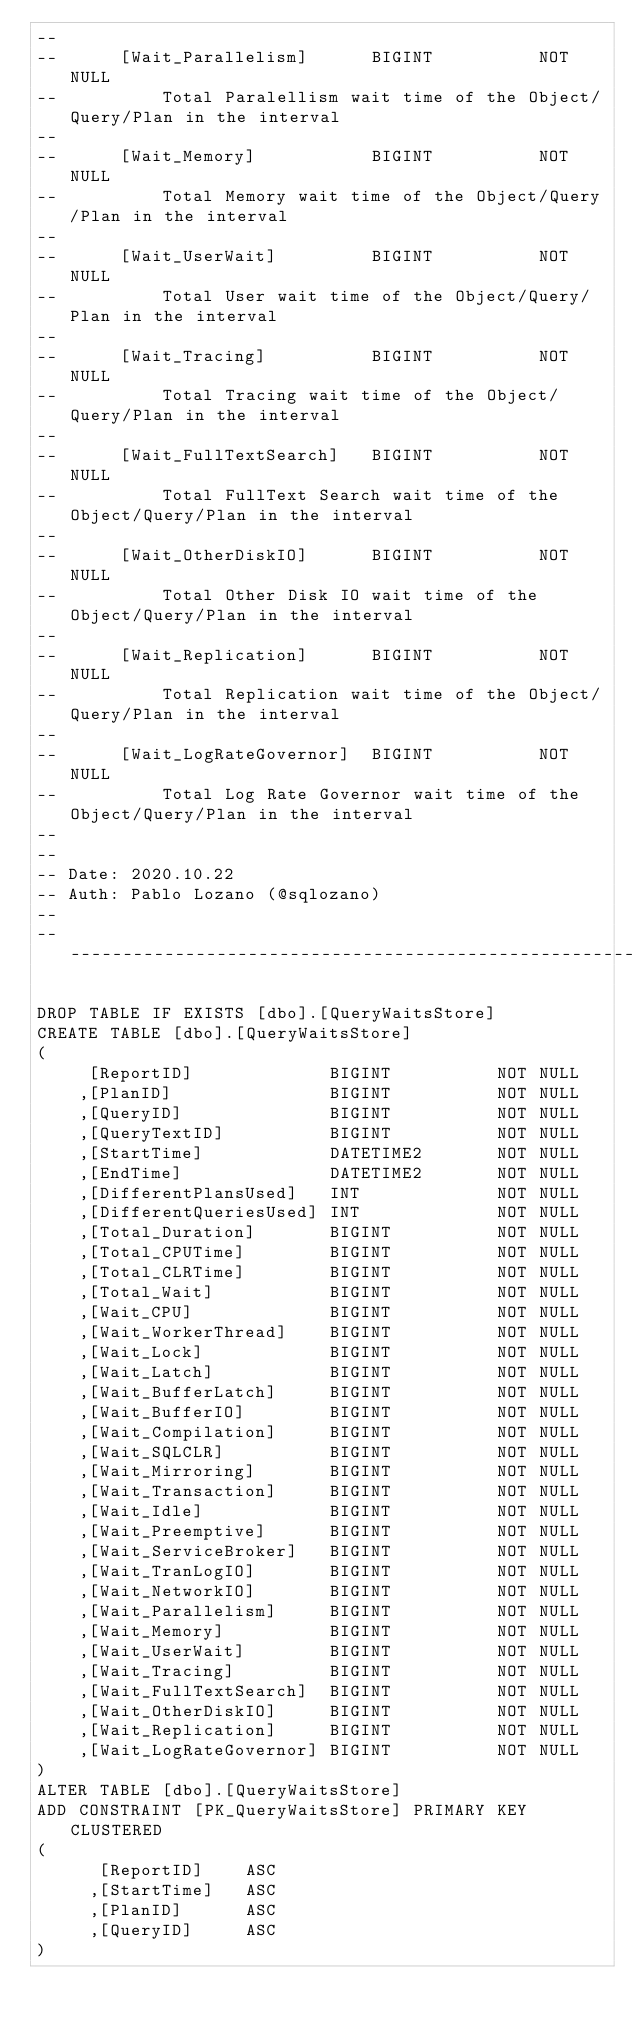<code> <loc_0><loc_0><loc_500><loc_500><_SQL_>--
--		[Wait_Parallelism]		BIGINT			NOT NULL
--			Total Paralellism wait time of the Object/Query/Plan in the interval
--
--		[Wait_Memory]			BIGINT			NOT NULL
--			Total Memory wait time of the Object/Query/Plan in the interval
--
--		[Wait_UserWait]			BIGINT			NOT NULL
--			Total User wait time of the Object/Query/Plan in the interval
--
--		[Wait_Tracing]			BIGINT			NOT NULL
--			Total Tracing wait time of the Object/Query/Plan in the interval
--
--		[Wait_FullTextSearch]	BIGINT			NOT NULL
--			Total FullText Search wait time of the Object/Query/Plan in the interval
--
--		[Wait_OtherDiskIO]		BIGINT			NOT NULL
--			Total Other Disk IO wait time of the Object/Query/Plan in the interval
--
--		[Wait_Replication]		BIGINT			NOT NULL
--			Total Replication wait time of the Object/Query/Plan in the interval
--
--		[Wait_LogRateGovernor]	BIGINT			NOT NULL
--			Total Log Rate Governor wait time of the Object/Query/Plan in the interval
--
--
-- Date: 2020.10.22
-- Auth: Pablo Lozano (@sqlozano)
--
----------------------------------------------------------------------------------

DROP TABLE IF EXISTS [dbo].[QueryWaitsStore]
CREATE TABLE [dbo].[QueryWaitsStore]
(
	 [ReportID]				BIGINT			NOT NULL
	,[PlanID]				BIGINT			NOT NULL
	,[QueryID]				BIGINT			NOT NULL
	,[QueryTextID]			BIGINT			NOT NULL
	,[StartTime]			DATETIME2		NOT NULL
	,[EndTime]				DATETIME2		NOT NULL
	,[DifferentPlansUsed]	INT				NOT NULL
	,[DifferentQueriesUsed]	INT				NOT NULL
	,[Total_Duration]		BIGINT			NOT NULL
	,[Total_CPUTime]		BIGINT			NOT NULL
	,[Total_CLRTime]		BIGINT			NOT NULL
	,[Total_Wait]			BIGINT			NOT NULL
	,[Wait_CPU]				BIGINT			NOT NULL
	,[Wait_WorkerThread]	BIGINT			NOT NULL
	,[Wait_Lock]			BIGINT			NOT NULL
	,[Wait_Latch]			BIGINT			NOT NULL
	,[Wait_BufferLatch]		BIGINT			NOT NULL
	,[Wait_BufferIO]		BIGINT			NOT NULL
	,[Wait_Compilation]		BIGINT			NOT NULL
	,[Wait_SQLCLR]			BIGINT			NOT NULL
	,[Wait_Mirroring]		BIGINT			NOT NULL
	,[Wait_Transaction]		BIGINT			NOT NULL
	,[Wait_Idle]			BIGINT			NOT NULL
	,[Wait_Preemptive]		BIGINT			NOT NULL
	,[Wait_ServiceBroker]	BIGINT			NOT NULL
	,[Wait_TranLogIO]		BIGINT			NOT NULL
	,[Wait_NetworkIO]		BIGINT			NOT NULL
	,[Wait_Parallelism]		BIGINT			NOT NULL
	,[Wait_Memory]			BIGINT			NOT NULL
	,[Wait_UserWait]		BIGINT			NOT NULL
	,[Wait_Tracing]			BIGINT			NOT NULL
	,[Wait_FullTextSearch]	BIGINT			NOT NULL
	,[Wait_OtherDiskIO]		BIGINT			NOT NULL
	,[Wait_Replication]		BIGINT			NOT NULL
	,[Wait_LogRateGovernor]	BIGINT			NOT NULL
)
ALTER TABLE [dbo].[QueryWaitsStore]
ADD CONSTRAINT [PK_QueryWaitsStore] PRIMARY KEY CLUSTERED
(
	  [ReportID]	ASC
	 ,[StartTime]	ASC
	 ,[PlanID]		ASC
	 ,[QueryID]		ASC
)</code> 